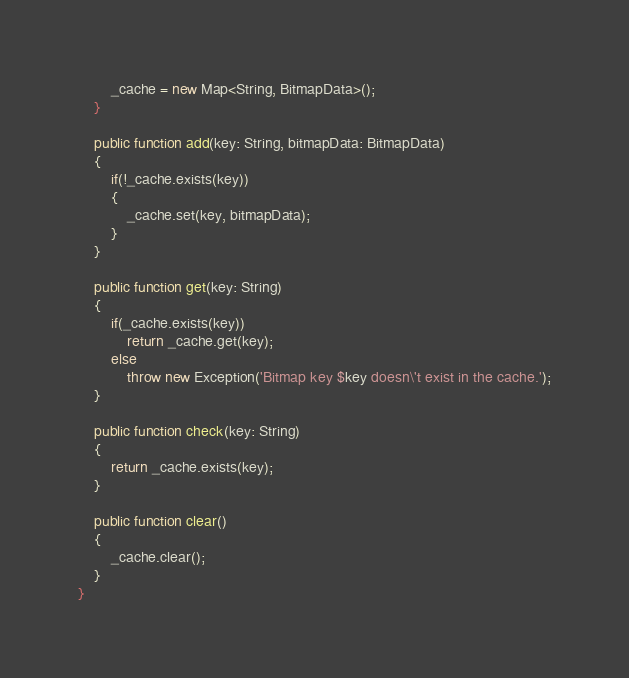<code> <loc_0><loc_0><loc_500><loc_500><_Haxe_>        _cache = new Map<String, BitmapData>();
    }

    public function add(key: String, bitmapData: BitmapData)
    {
        if(!_cache.exists(key))
        {
            _cache.set(key, bitmapData);
        }
    }

    public function get(key: String)
    {
        if(_cache.exists(key))
            return _cache.get(key);
        else
            throw new Exception('Bitmap key $key doesn\'t exist in the cache.');
    }

    public function check(key: String)
    {
        return _cache.exists(key);
    }

    public function clear()
    {
        _cache.clear();
    }
}</code> 